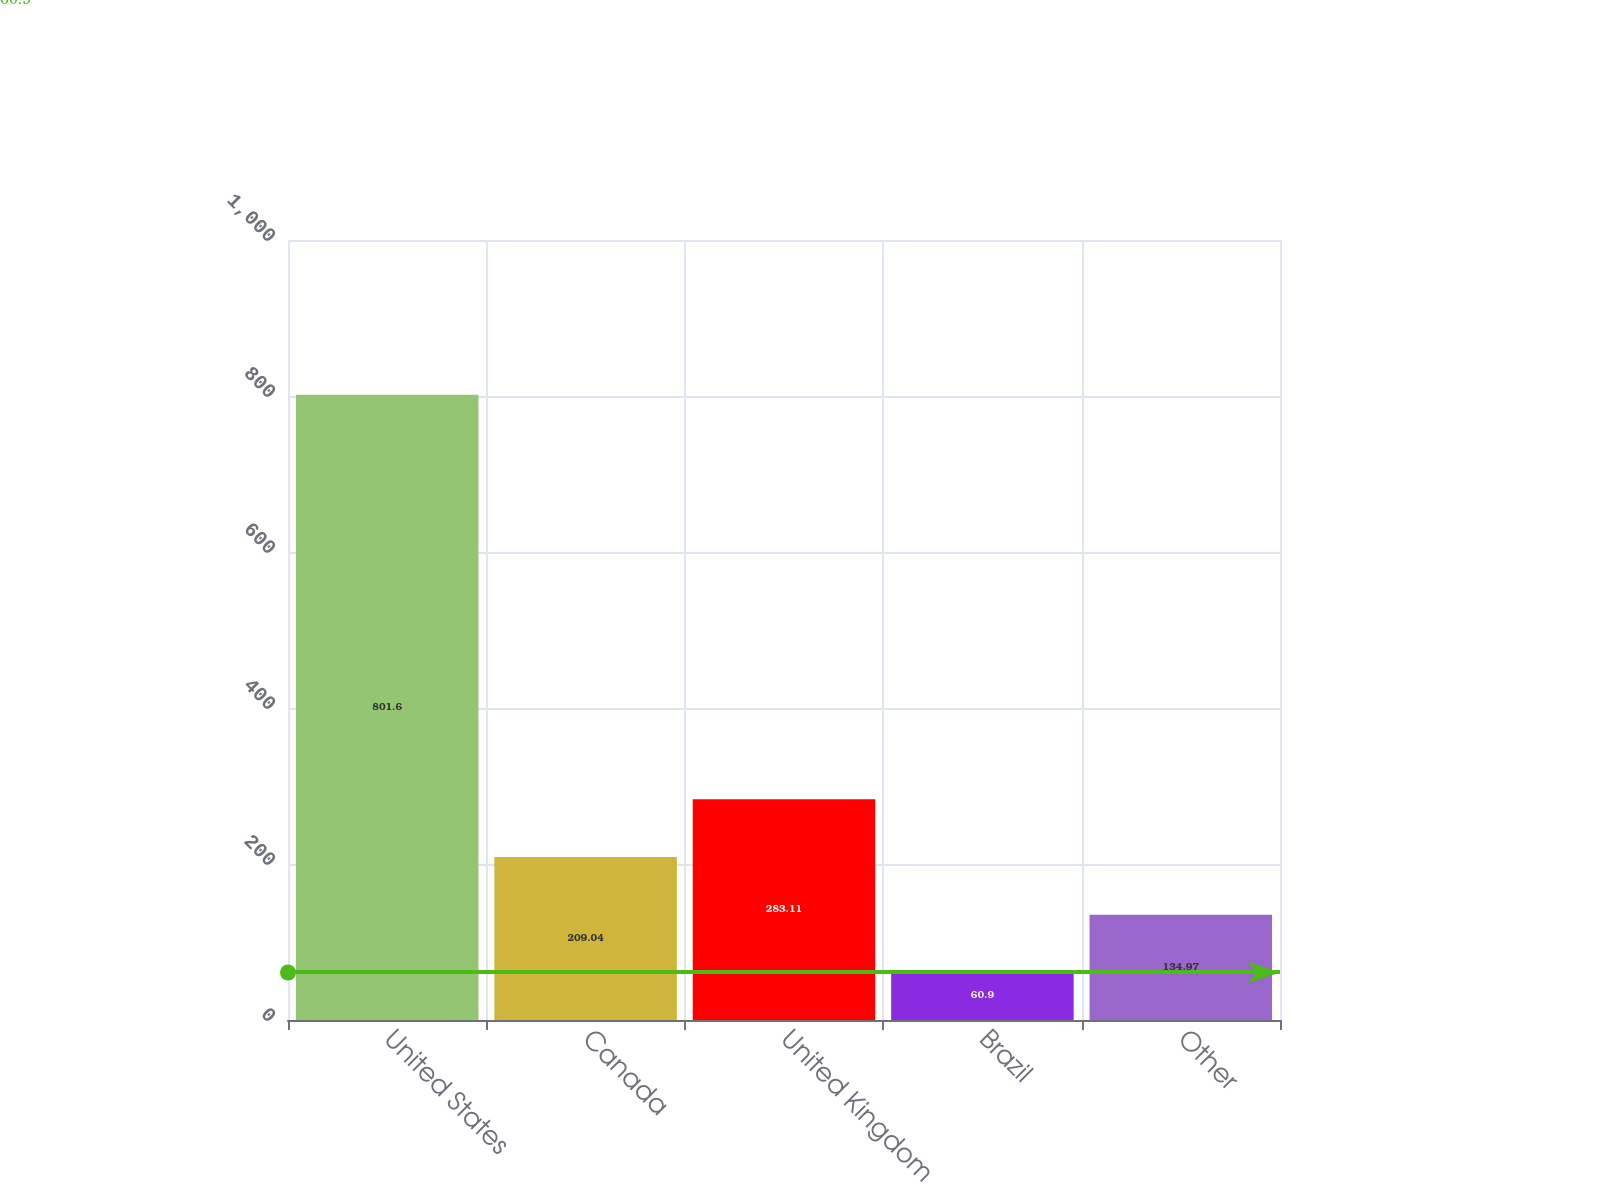<chart> <loc_0><loc_0><loc_500><loc_500><bar_chart><fcel>United States<fcel>Canada<fcel>United Kingdom<fcel>Brazil<fcel>Other<nl><fcel>801.6<fcel>209.04<fcel>283.11<fcel>60.9<fcel>134.97<nl></chart> 